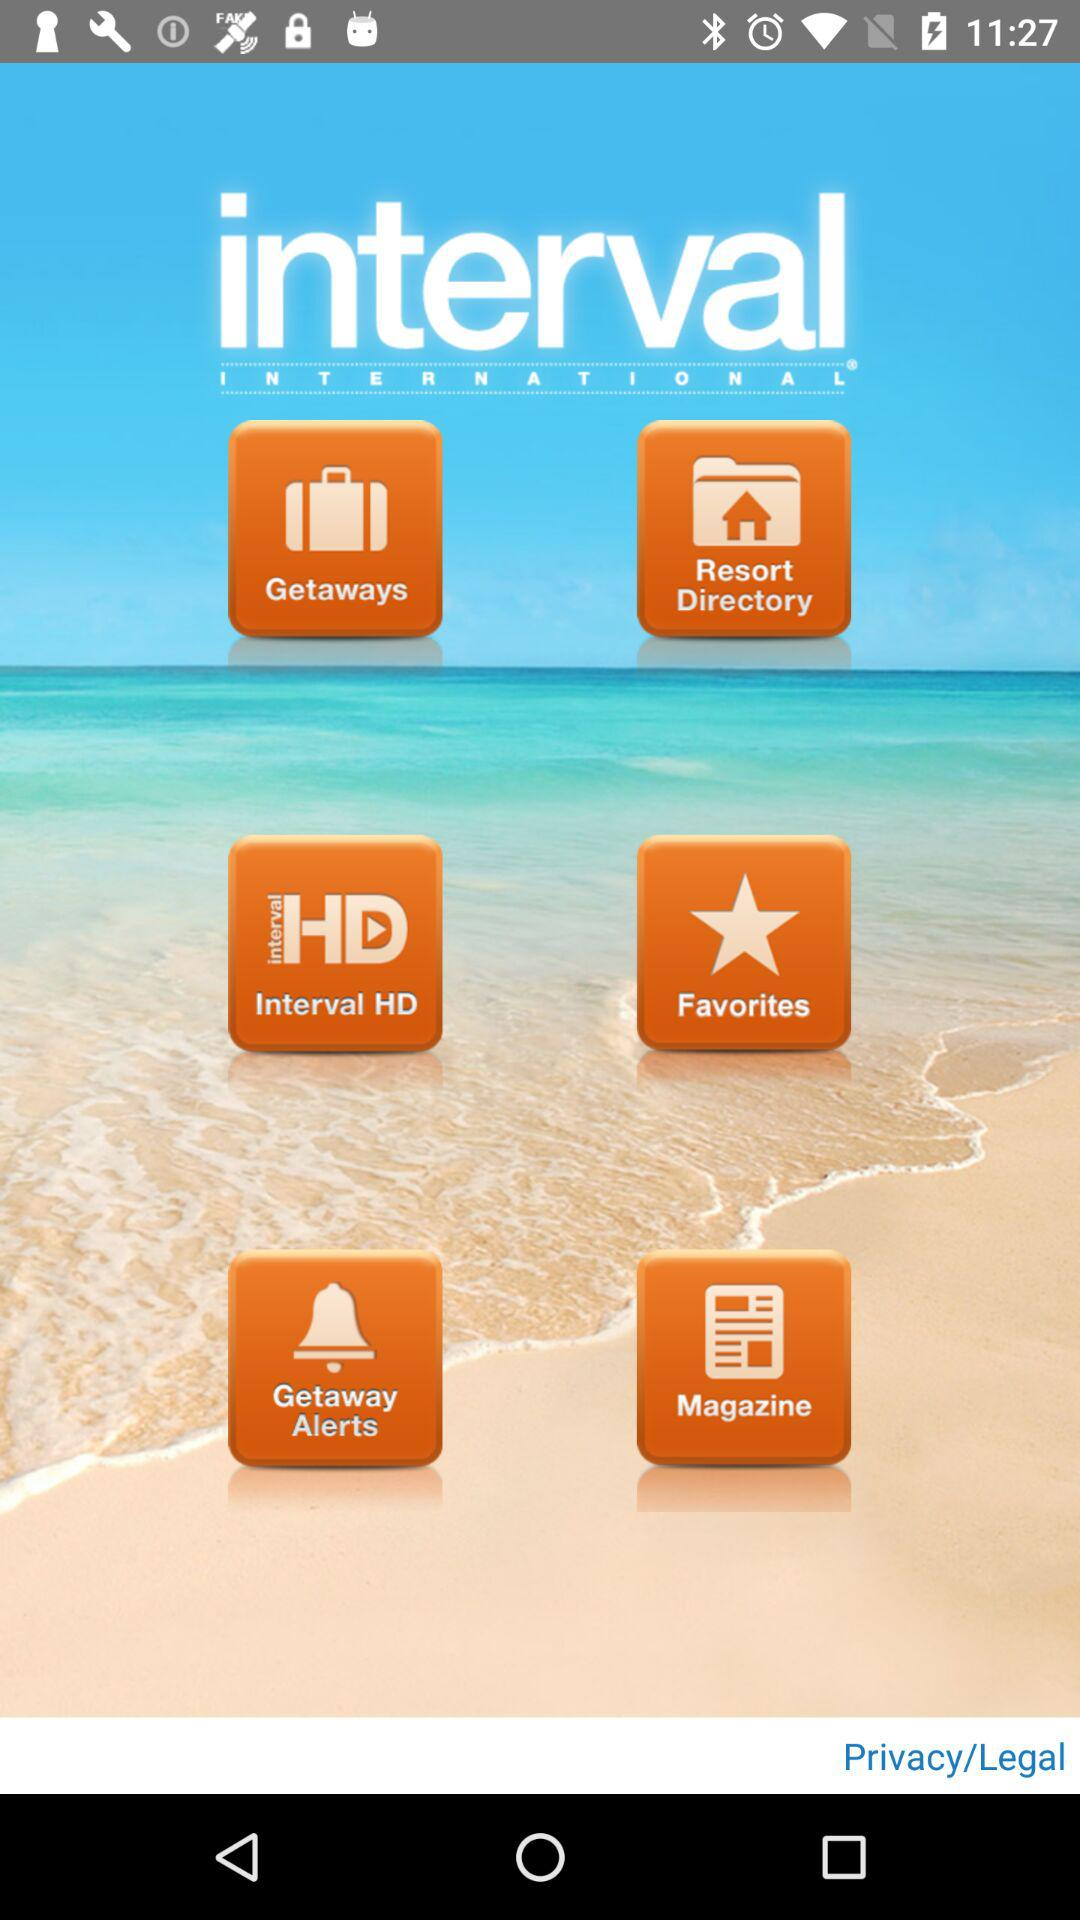What is the name of application? The application name is "interval INTERNATIONAL". 